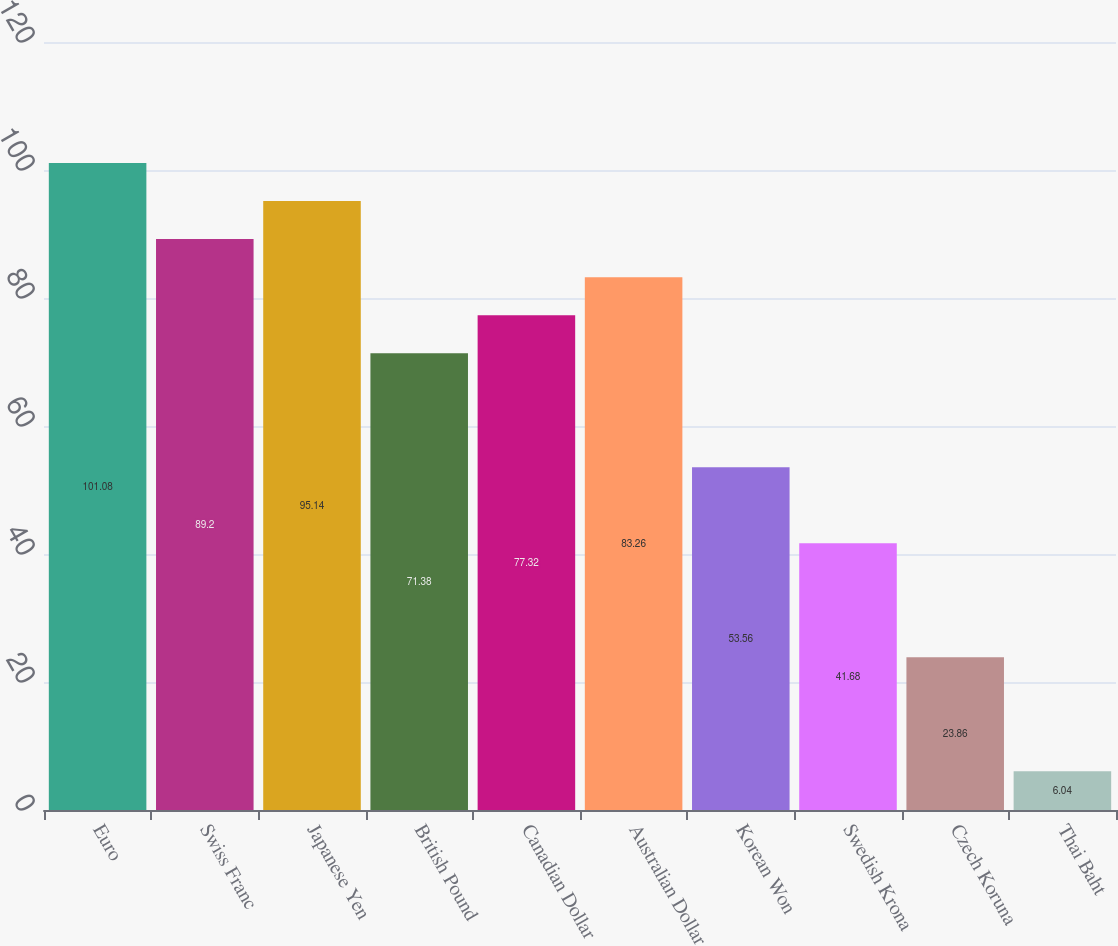Convert chart. <chart><loc_0><loc_0><loc_500><loc_500><bar_chart><fcel>Euro<fcel>Swiss Franc<fcel>Japanese Yen<fcel>British Pound<fcel>Canadian Dollar<fcel>Australian Dollar<fcel>Korean Won<fcel>Swedish Krona<fcel>Czech Koruna<fcel>Thai Baht<nl><fcel>101.08<fcel>89.2<fcel>95.14<fcel>71.38<fcel>77.32<fcel>83.26<fcel>53.56<fcel>41.68<fcel>23.86<fcel>6.04<nl></chart> 